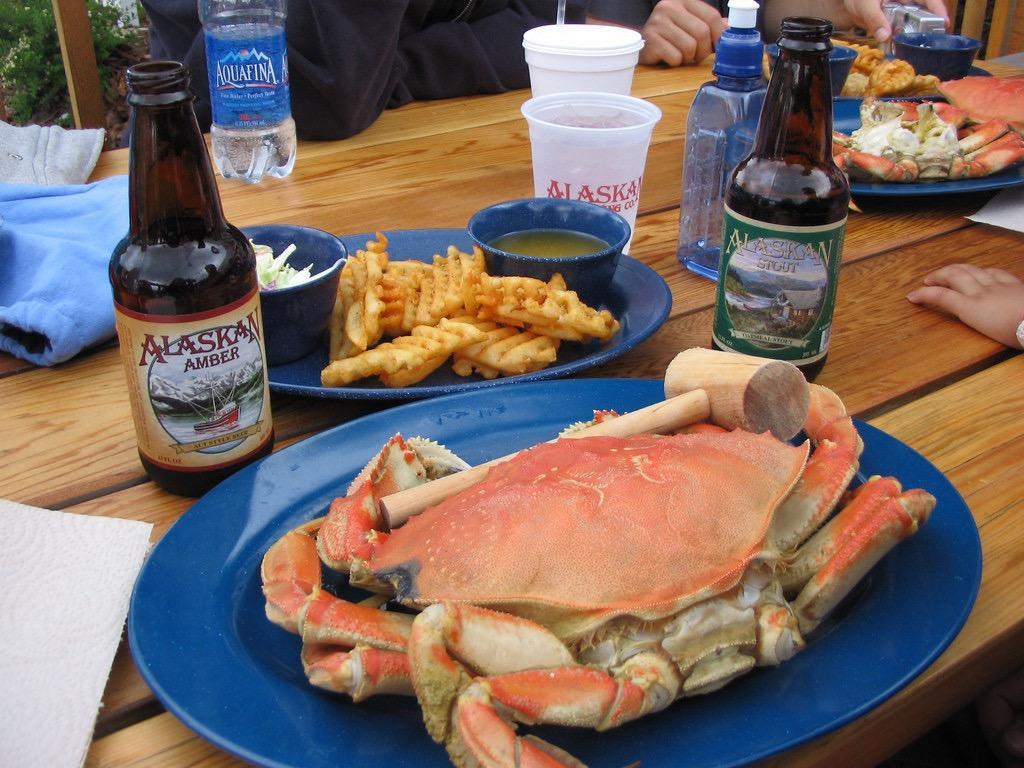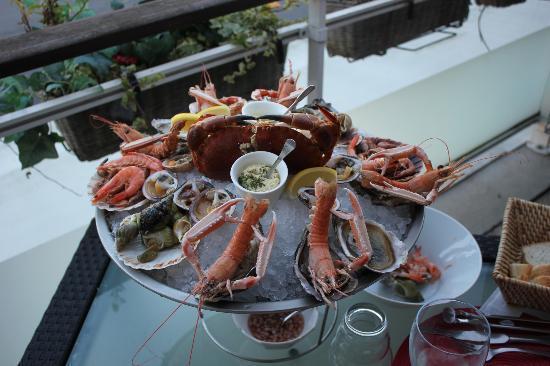The first image is the image on the left, the second image is the image on the right. Analyze the images presented: Is the assertion "In the right image, one woman is sitting at a table behind a round bowl filled with crabs legs, a smaller filled white bowl and other items." valid? Answer yes or no. No. The first image is the image on the left, the second image is the image on the right. Given the left and right images, does the statement "A single person who is a woman is sitting behind a platter of seafood in one of the images." hold true? Answer yes or no. No. 